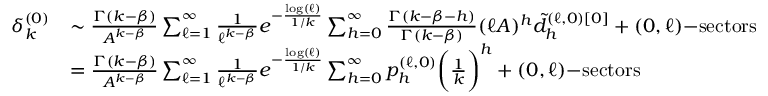Convert formula to latex. <formula><loc_0><loc_0><loc_500><loc_500>\begin{array} { r l } { \delta _ { k } ^ { ( 0 ) } } & { \sim \frac { \Gamma ( k - \beta ) } { A ^ { k - \beta } } \sum _ { \ell = 1 } ^ { \infty } \frac { 1 } { \ell ^ { k - \beta } } e ^ { - \frac { \log ( \ell ) } { 1 / k } } \sum _ { h = 0 } ^ { \infty } \frac { \Gamma ( k - \beta - h ) } { \Gamma ( k - \beta ) } ( \ell A ) ^ { h } \tilde { d } _ { h } ^ { ( \ell , 0 ) [ 0 ] } + ( 0 , \ell ) - s e c t o r s } \\ & { = \frac { \Gamma ( k - \beta ) } { A ^ { k - \beta } } \sum _ { \ell = 1 } ^ { \infty } \frac { 1 } { \ell ^ { k - \beta } } e ^ { - \frac { \log ( \ell ) } { 1 / k } } \sum _ { h = 0 } ^ { \infty } p _ { h } ^ { ( \ell , 0 ) } \left ( \frac { 1 } { k } \right ) ^ { h } + ( 0 , \ell ) - s e c t o r s } \end{array}</formula> 